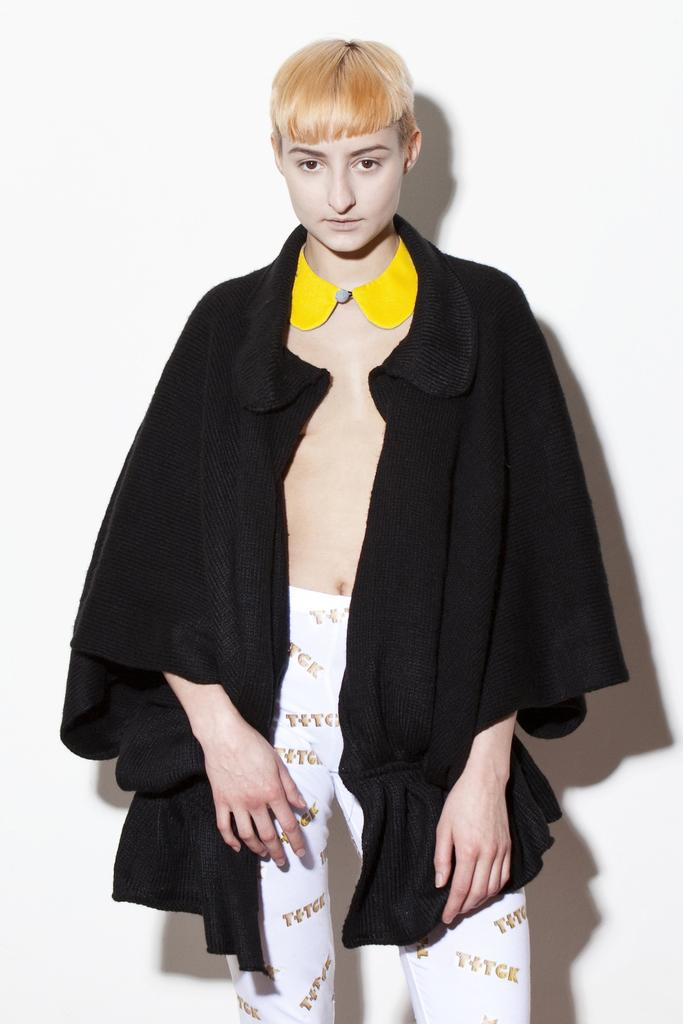What is the main subject of the image? There is a human standing in the image. What is the human wearing in the image? The human is wearing a black coat and a yellow bow tie. What is the color of the background in the image? The background of the image is white. What type of grain can be seen growing in the image? There is no grain present in the image; it features a human wearing a black coat and a yellow bow tie against a white background. 